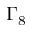Convert formula to latex. <formula><loc_0><loc_0><loc_500><loc_500>\Gamma _ { 8 }</formula> 